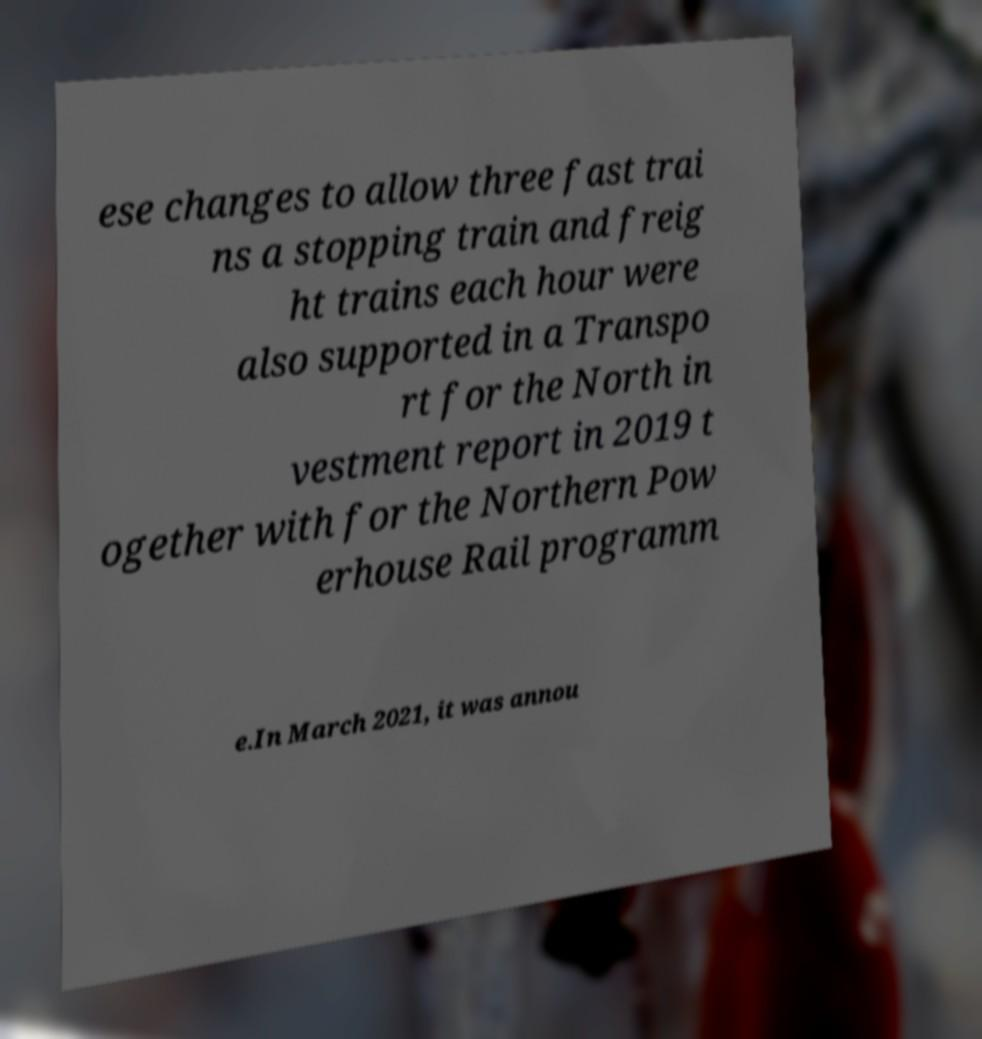Can you read and provide the text displayed in the image?This photo seems to have some interesting text. Can you extract and type it out for me? ese changes to allow three fast trai ns a stopping train and freig ht trains each hour were also supported in a Transpo rt for the North in vestment report in 2019 t ogether with for the Northern Pow erhouse Rail programm e.In March 2021, it was annou 